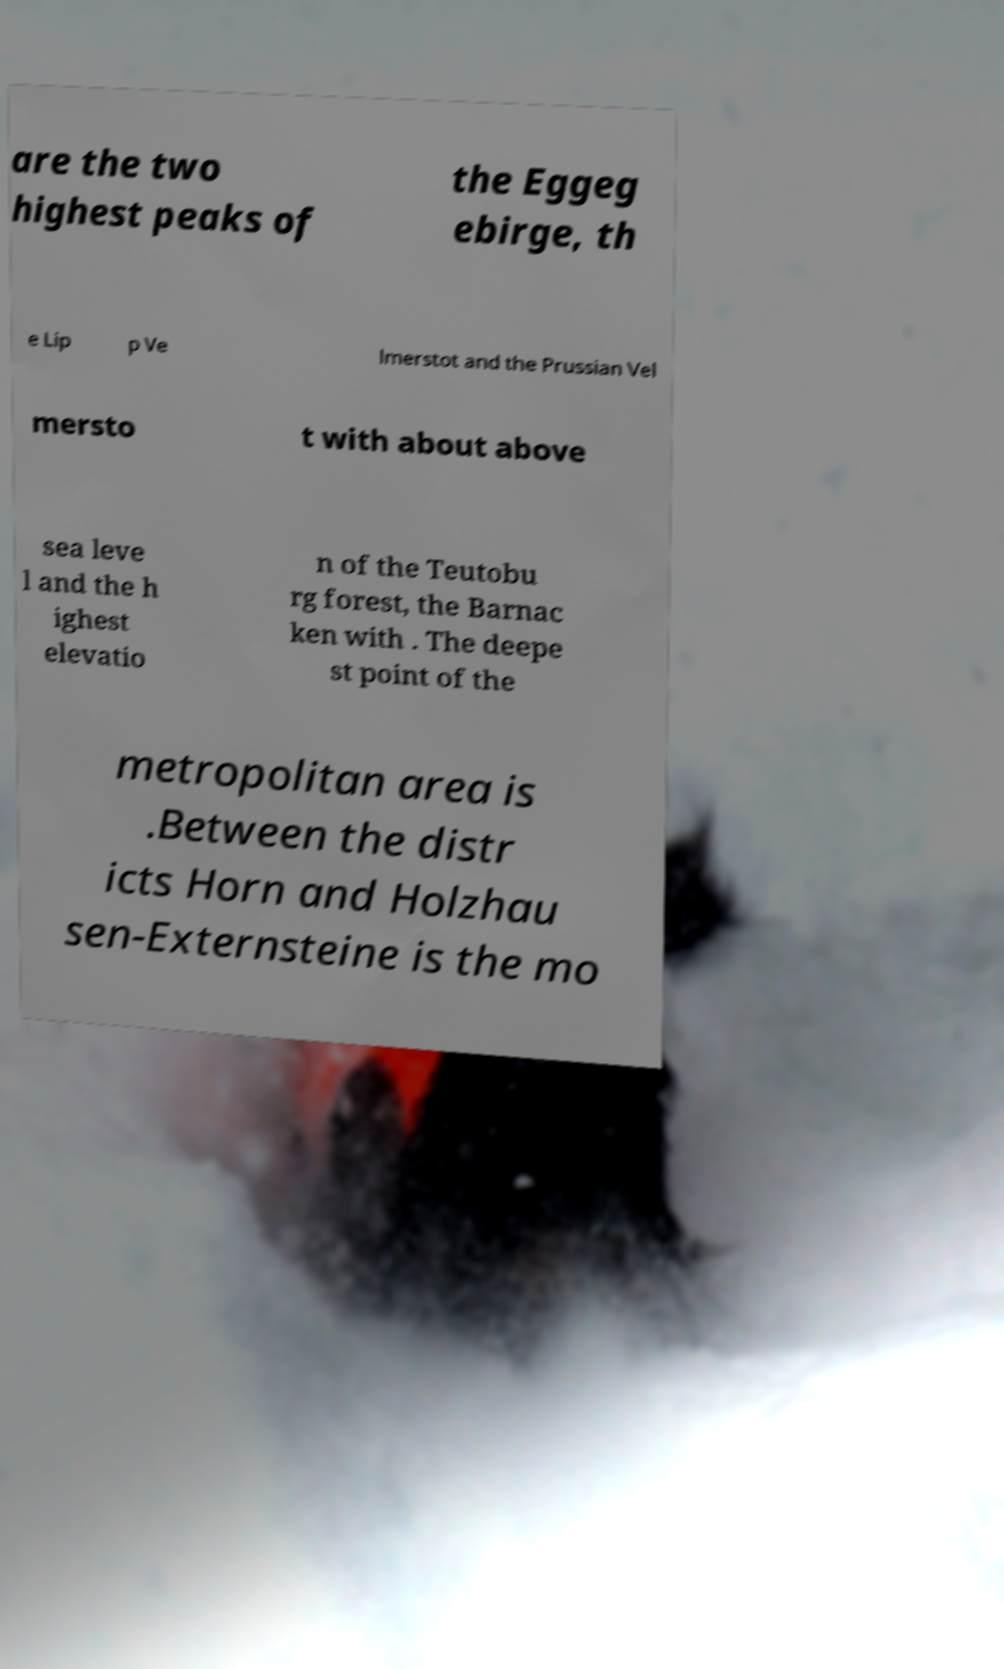Please identify and transcribe the text found in this image. are the two highest peaks of the Eggeg ebirge, th e Lip p Ve lmerstot and the Prussian Vel mersto t with about above sea leve l and the h ighest elevatio n of the Teutobu rg forest, the Barnac ken with . The deepe st point of the metropolitan area is .Between the distr icts Horn and Holzhau sen-Externsteine is the mo 